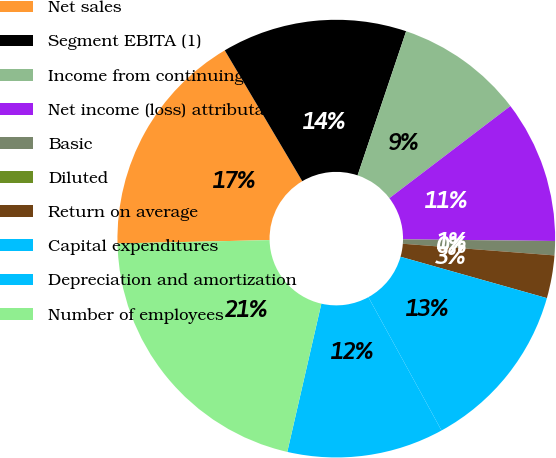Convert chart. <chart><loc_0><loc_0><loc_500><loc_500><pie_chart><fcel>Net sales<fcel>Segment EBITA (1)<fcel>Income from continuing<fcel>Net income (loss) attributable<fcel>Basic<fcel>Diluted<fcel>Return on average<fcel>Capital expenditures<fcel>Depreciation and amortization<fcel>Number of employees<nl><fcel>16.84%<fcel>13.68%<fcel>9.47%<fcel>10.53%<fcel>1.05%<fcel>0.0%<fcel>3.16%<fcel>12.63%<fcel>11.58%<fcel>21.05%<nl></chart> 